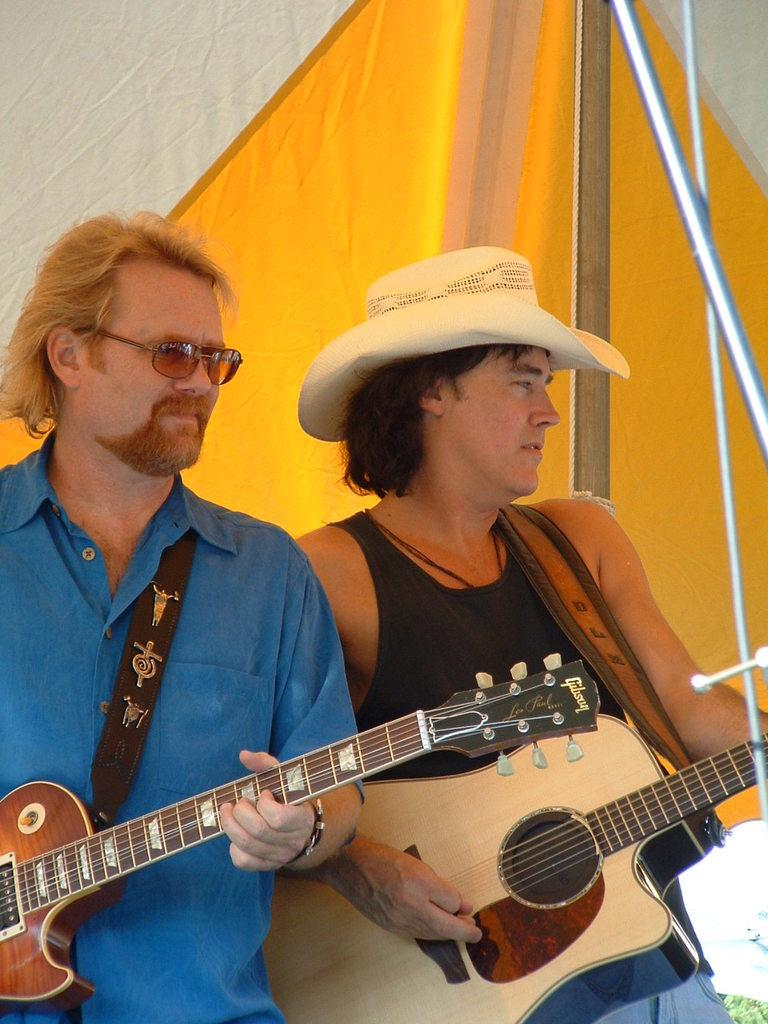How many people are in the image? There are two persons in the image. Where are the two persons located? The two persons are inside a tent. What is one of the persons doing in the image? One of the persons is playing a guitar. Can you describe the appearance of the person on the right side? The person on the right side is wearing a cap. How many toes can be seen on the person playing the guitar in the image? There is no information about the person's toes in the image, so it cannot be determined. Are there any icicles hanging from the tent in the image? There is no mention of icicles in the image, so it cannot be determined if any are present. 